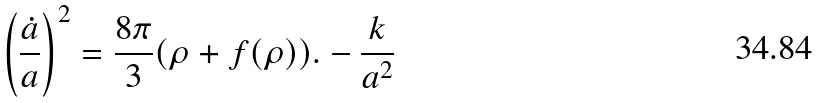<formula> <loc_0><loc_0><loc_500><loc_500>\left ( \frac { \dot { a } } { a } \right ) ^ { 2 } = \frac { 8 \pi } 3 ( \rho + f ( \rho ) ) . - \frac { k } { a ^ { 2 } }</formula> 